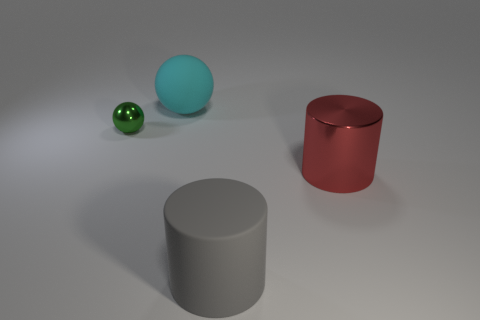Add 1 large red rubber blocks. How many objects exist? 5 Add 4 green metallic balls. How many green metallic balls exist? 5 Subtract 0 brown spheres. How many objects are left? 4 Subtract all gray rubber cylinders. Subtract all matte cylinders. How many objects are left? 2 Add 4 gray things. How many gray things are left? 5 